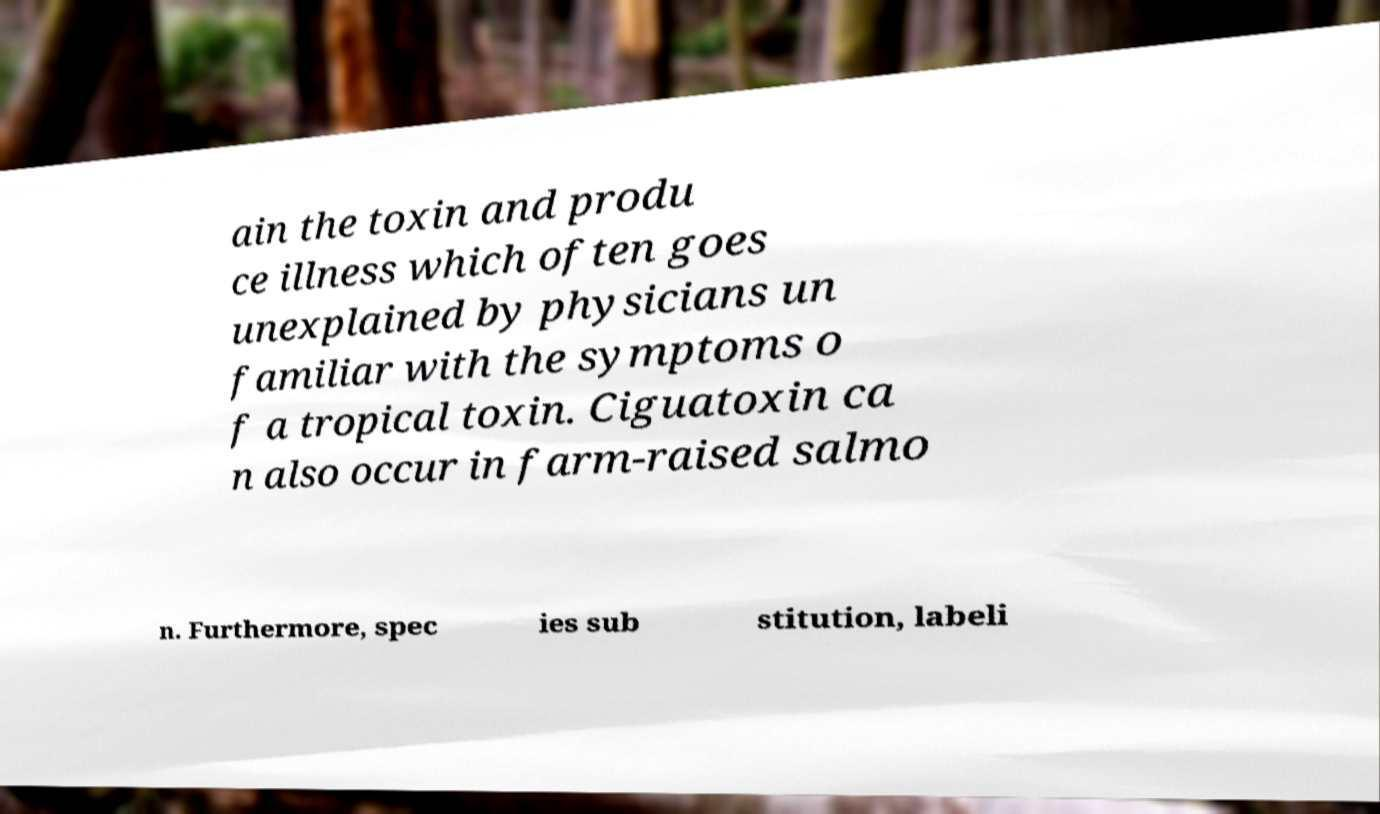For documentation purposes, I need the text within this image transcribed. Could you provide that? ain the toxin and produ ce illness which often goes unexplained by physicians un familiar with the symptoms o f a tropical toxin. Ciguatoxin ca n also occur in farm-raised salmo n. Furthermore, spec ies sub stitution, labeli 